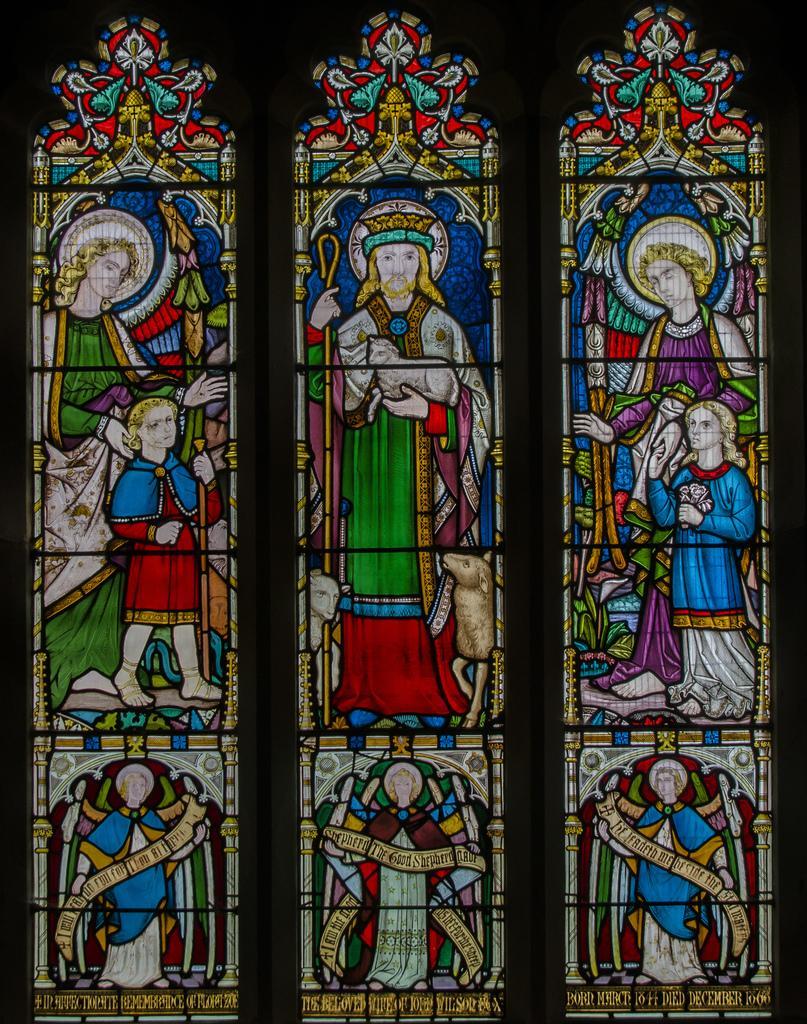In one or two sentences, can you explain what this image depicts? In this image we can see a stained glass. 